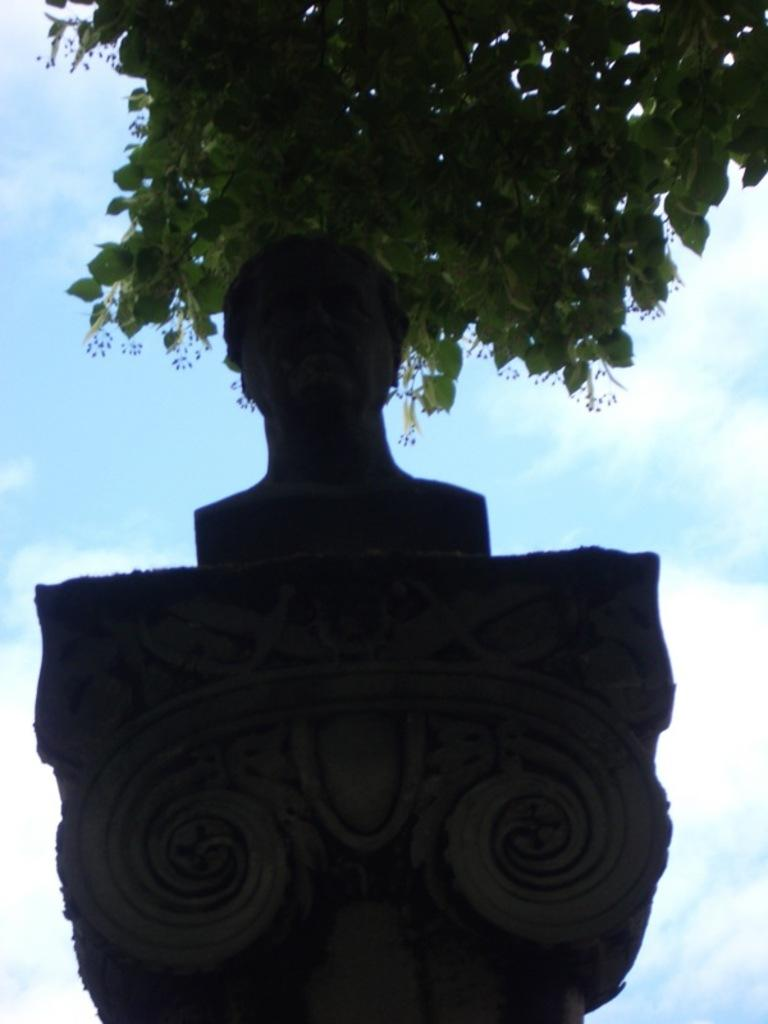What is the main subject of the image? There is a sculpture of a person on a pillar in the image. What other objects or elements can be seen in the image? There is a tree in the image. What can be seen in the background of the image? The sky is visible in the background of the image. How does the rabbit twist around the sculpture in the image? There is no rabbit present in the image, and therefore no such activity can be observed. 